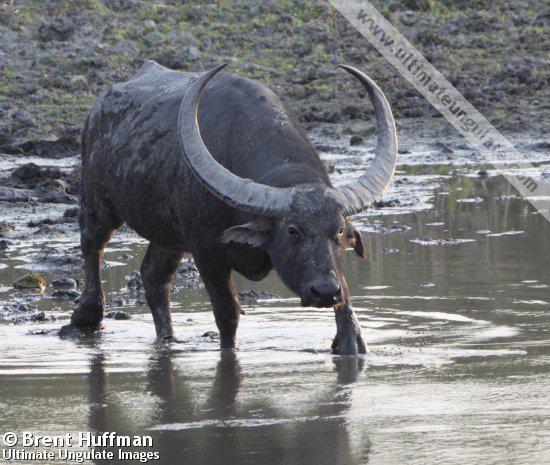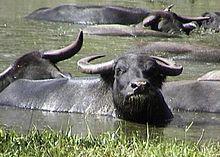The first image is the image on the left, the second image is the image on the right. Assess this claim about the two images: "An image shows one water buffalo standing in water that does not reach its chest.". Correct or not? Answer yes or no. Yes. The first image is the image on the left, the second image is the image on the right. Considering the images on both sides, is "An image contains a water buffalo standing on water." valid? Answer yes or no. Yes. 